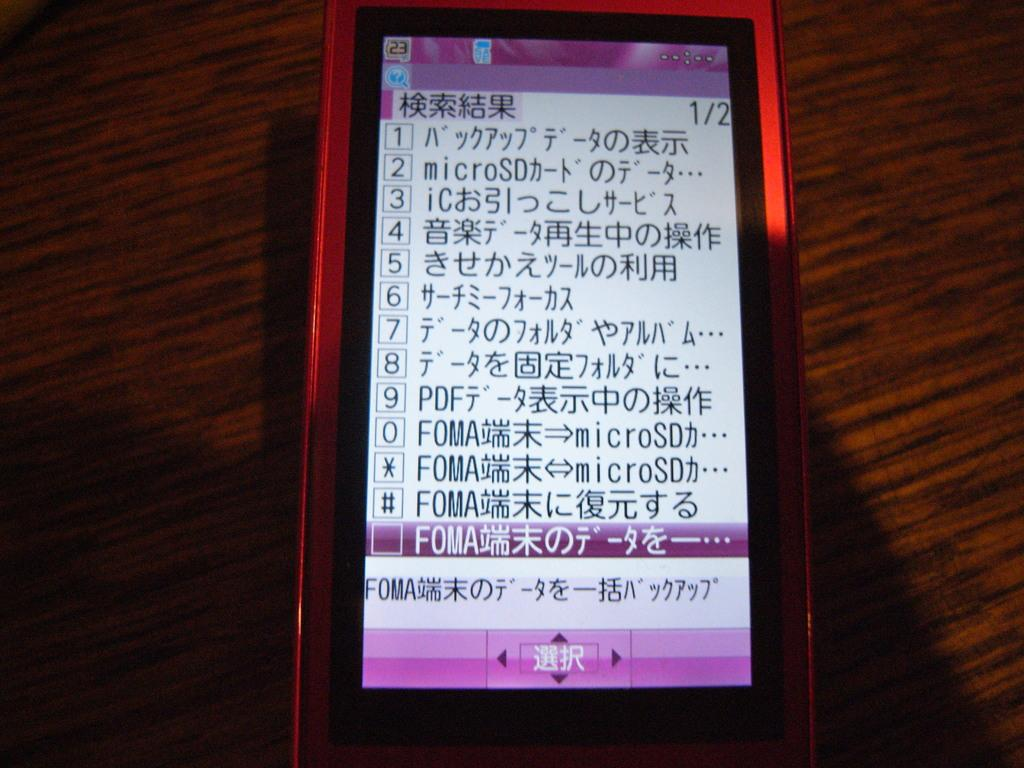<image>
Provide a brief description of the given image. A cellphone sitting on a table with numbers and symbols and some of them read FOMA. 